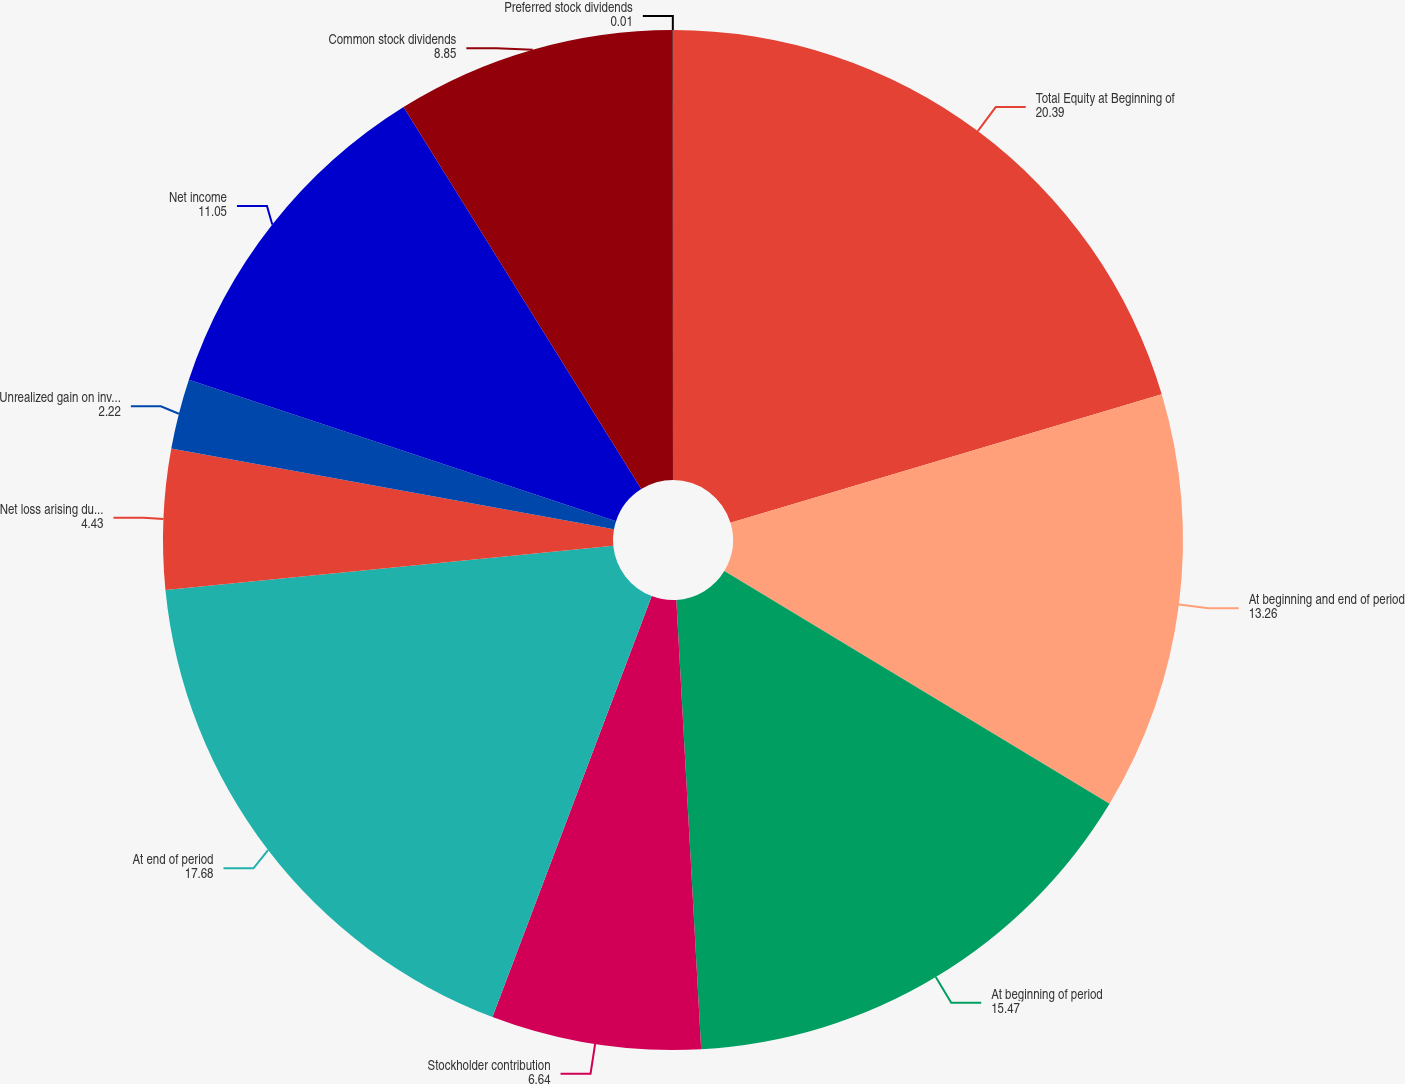Convert chart. <chart><loc_0><loc_0><loc_500><loc_500><pie_chart><fcel>Total Equity at Beginning of<fcel>At beginning and end of period<fcel>At beginning of period<fcel>Stockholder contribution<fcel>At end of period<fcel>Net loss arising during the<fcel>Unrealized gain on investments<fcel>Net income<fcel>Common stock dividends<fcel>Preferred stock dividends<nl><fcel>20.39%<fcel>13.26%<fcel>15.47%<fcel>6.64%<fcel>17.68%<fcel>4.43%<fcel>2.22%<fcel>11.05%<fcel>8.85%<fcel>0.01%<nl></chart> 